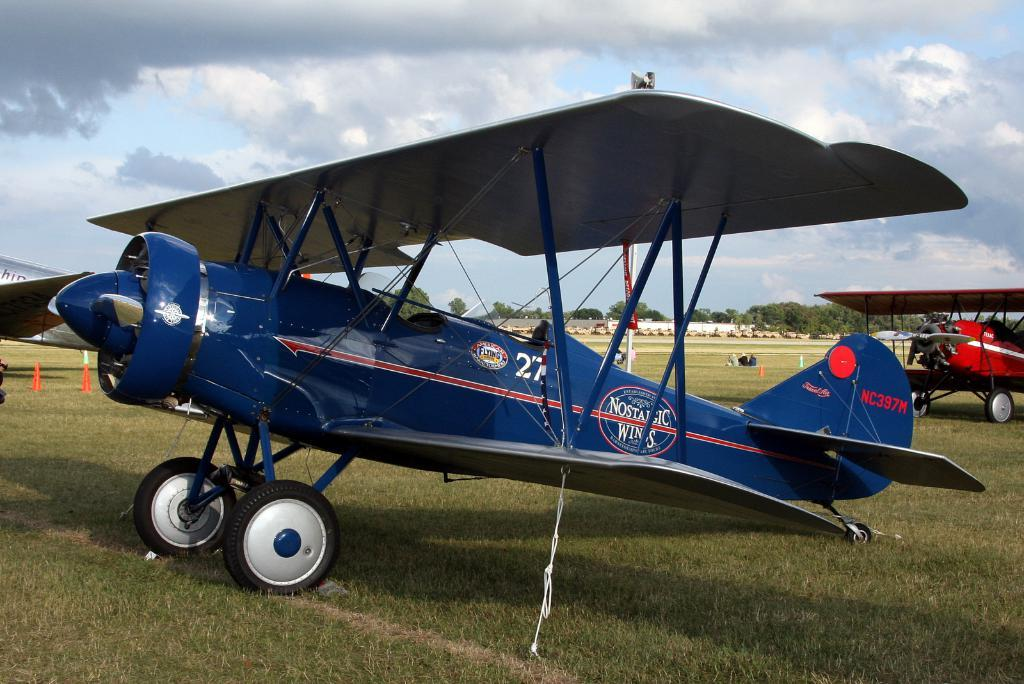What type of vehicles are on the ground in the image? There are air crafts on the ground in the image. Can you describe the people in the image? There are people in the image, but their specific actions or appearances are not mentioned in the facts. What safety or guidance objects are present in the image? Traffic cones are present in the image. What type of natural elements can be seen in the image? There are trees in the image. What else can be seen in the image besides the air crafts, people, and trees? There are objects in the image, but their specific nature is not mentioned in the facts. What is visible in the background of the image? The sky with clouds is visible in the background of the image. What type of insect can be seen crawling on the tin in the image? There is no insect or tin present in the image. What type of drain is visible in the image? There is no drain present in the image. 